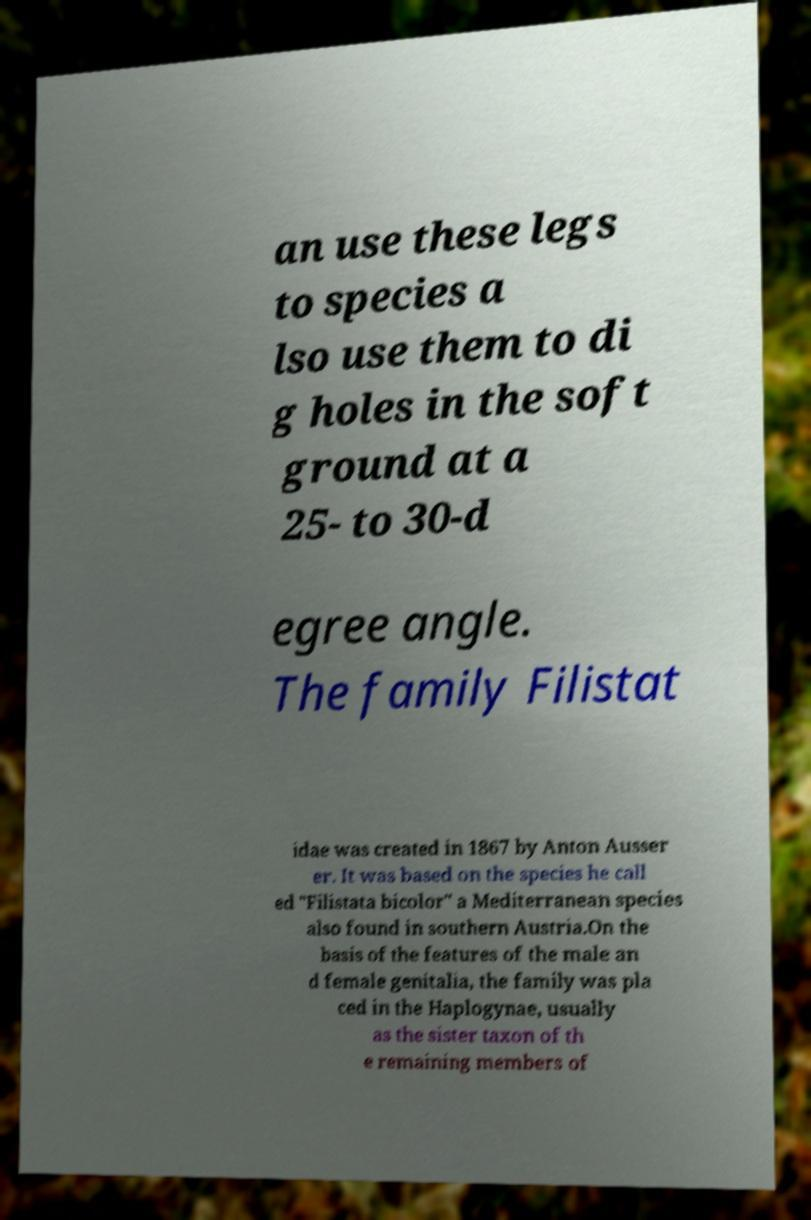For documentation purposes, I need the text within this image transcribed. Could you provide that? an use these legs to species a lso use them to di g holes in the soft ground at a 25- to 30-d egree angle. The family Filistat idae was created in 1867 by Anton Ausser er. It was based on the species he call ed "Filistata bicolor" a Mediterranean species also found in southern Austria.On the basis of the features of the male an d female genitalia, the family was pla ced in the Haplogynae, usually as the sister taxon of th e remaining members of 